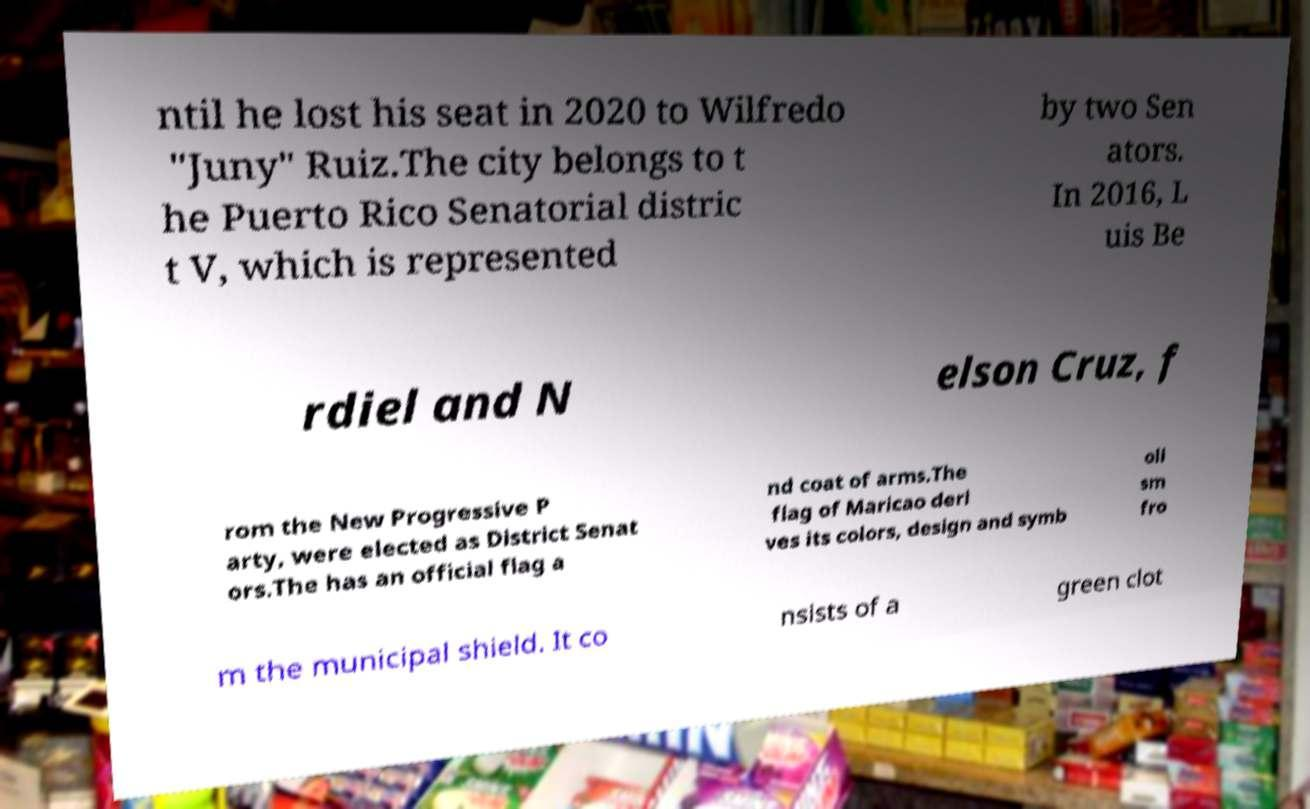There's text embedded in this image that I need extracted. Can you transcribe it verbatim? ntil he lost his seat in 2020 to Wilfredo "Juny" Ruiz.The city belongs to t he Puerto Rico Senatorial distric t V, which is represented by two Sen ators. In 2016, L uis Be rdiel and N elson Cruz, f rom the New Progressive P arty, were elected as District Senat ors.The has an official flag a nd coat of arms.The flag of Maricao deri ves its colors, design and symb oli sm fro m the municipal shield. It co nsists of a green clot 